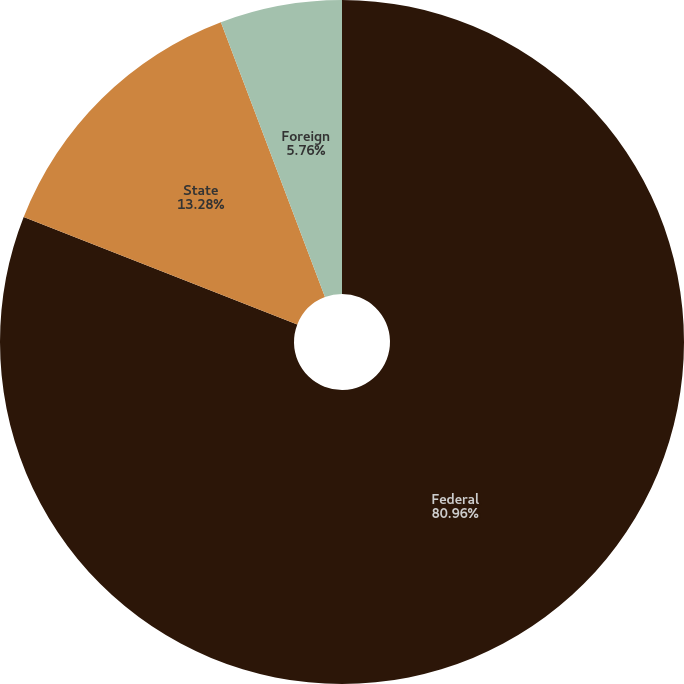Convert chart to OTSL. <chart><loc_0><loc_0><loc_500><loc_500><pie_chart><fcel>Federal<fcel>State<fcel>Foreign<nl><fcel>80.95%<fcel>13.28%<fcel>5.76%<nl></chart> 